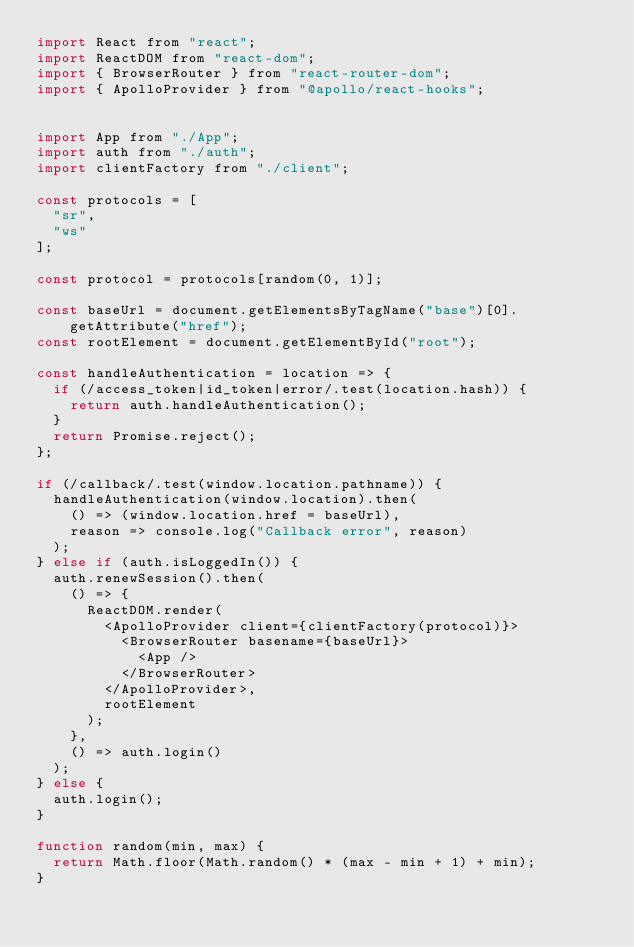Convert code to text. <code><loc_0><loc_0><loc_500><loc_500><_JavaScript_>import React from "react";
import ReactDOM from "react-dom";
import { BrowserRouter } from "react-router-dom";
import { ApolloProvider } from "@apollo/react-hooks";


import App from "./App";
import auth from "./auth";
import clientFactory from "./client";

const protocols = [
  "sr",
  "ws"
];

const protocol = protocols[random(0, 1)];

const baseUrl = document.getElementsByTagName("base")[0].getAttribute("href");
const rootElement = document.getElementById("root");

const handleAuthentication = location => {
  if (/access_token|id_token|error/.test(location.hash)) {
    return auth.handleAuthentication();
  }
  return Promise.reject();
};

if (/callback/.test(window.location.pathname)) {
  handleAuthentication(window.location).then(
    () => (window.location.href = baseUrl),
    reason => console.log("Callback error", reason)
  );
} else if (auth.isLoggedIn()) {
  auth.renewSession().then(
    () => {
      ReactDOM.render(
        <ApolloProvider client={clientFactory(protocol)}>
          <BrowserRouter basename={baseUrl}>
            <App />
          </BrowserRouter>
        </ApolloProvider>,
        rootElement
      );
    },
    () => auth.login()
  );
} else {
  auth.login();
}

function random(min, max) {
  return Math.floor(Math.random() * (max - min + 1) + min);
}
</code> 